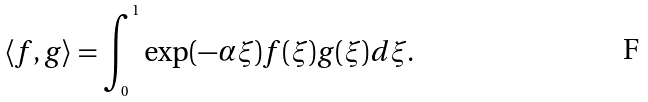Convert formula to latex. <formula><loc_0><loc_0><loc_500><loc_500>\langle f , g \rangle = \int _ { _ { 0 } } ^ { ^ { 1 } } \exp ( - \alpha \xi ) f ( \xi ) g ( \xi ) d \xi .</formula> 